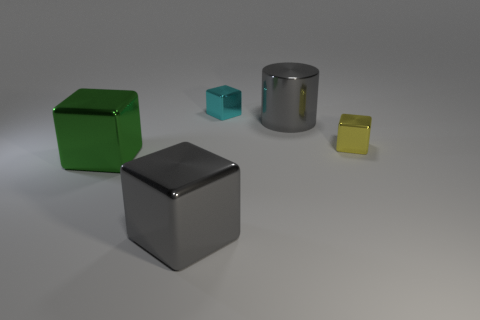Subtract all blue cubes. Subtract all purple spheres. How many cubes are left? 4 Add 5 cyan matte cylinders. How many objects exist? 10 Subtract all cubes. How many objects are left? 1 Subtract all cyan objects. Subtract all gray shiny cylinders. How many objects are left? 3 Add 2 small yellow cubes. How many small yellow cubes are left? 3 Add 2 cyan metal objects. How many cyan metal objects exist? 3 Subtract 0 red spheres. How many objects are left? 5 